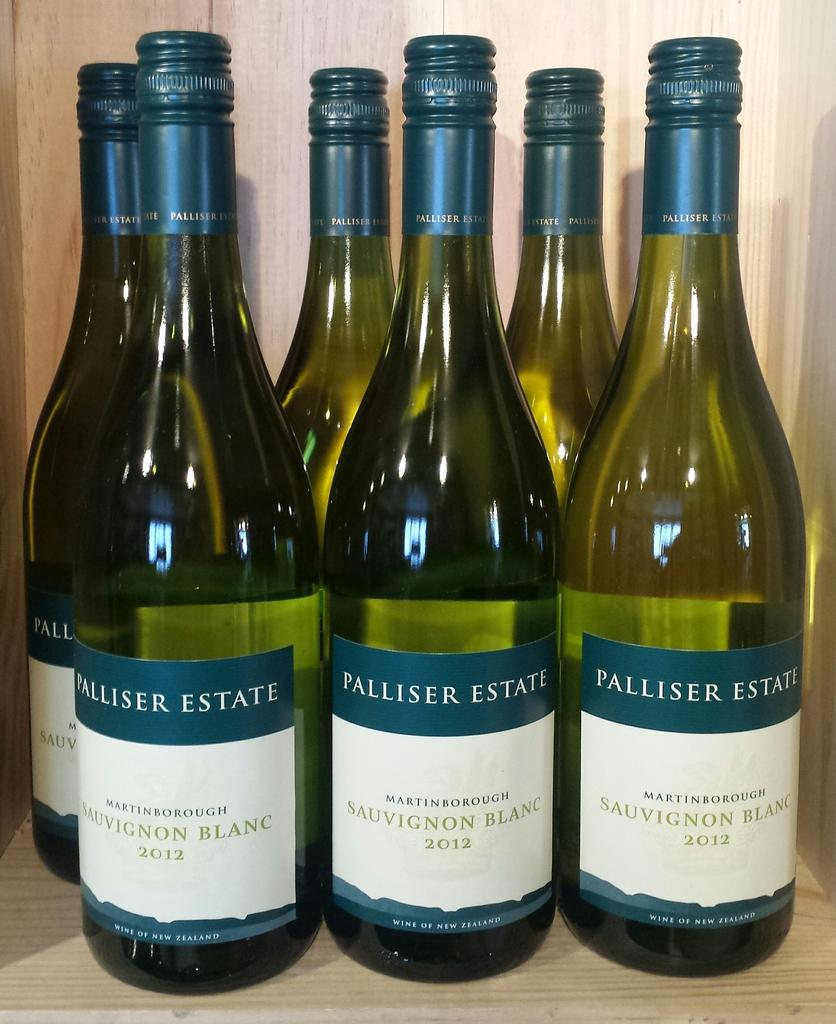<image>
Render a clear and concise summary of the photo. Several bottles of wine from the Palliser Estate brand with the variety Sauvignon Blanc written on their labels. 